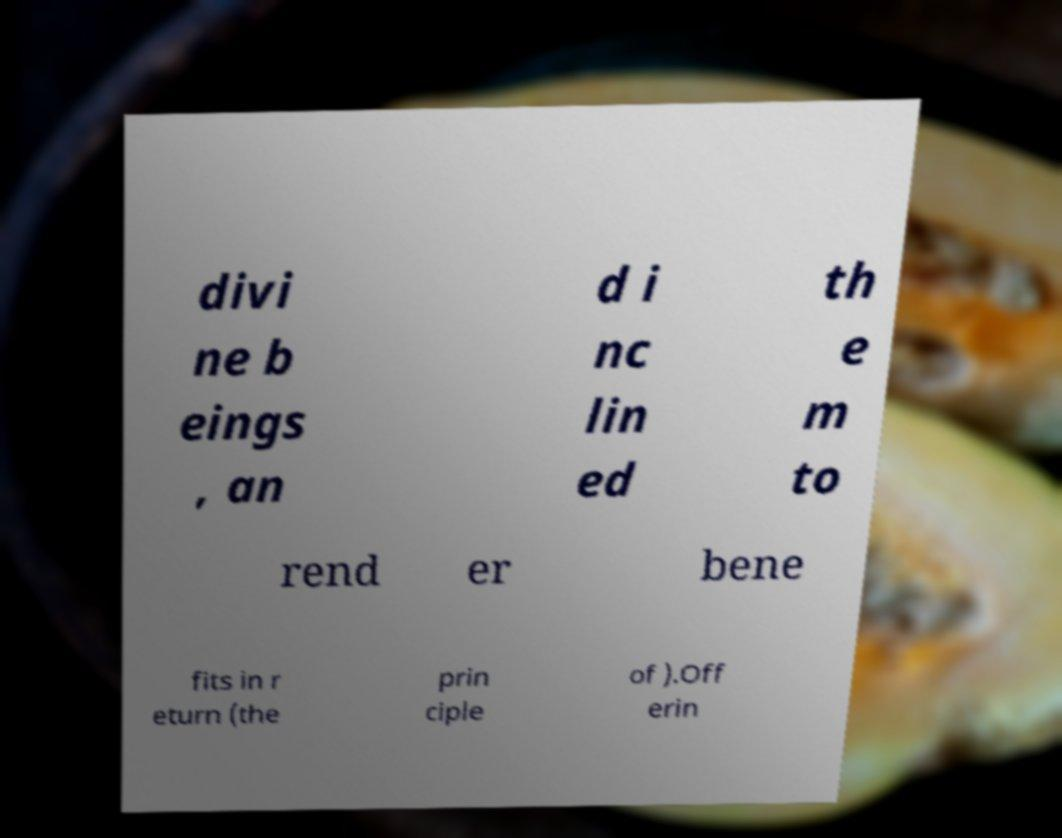For documentation purposes, I need the text within this image transcribed. Could you provide that? divi ne b eings , an d i nc lin ed th e m to rend er bene fits in r eturn (the prin ciple of ).Off erin 